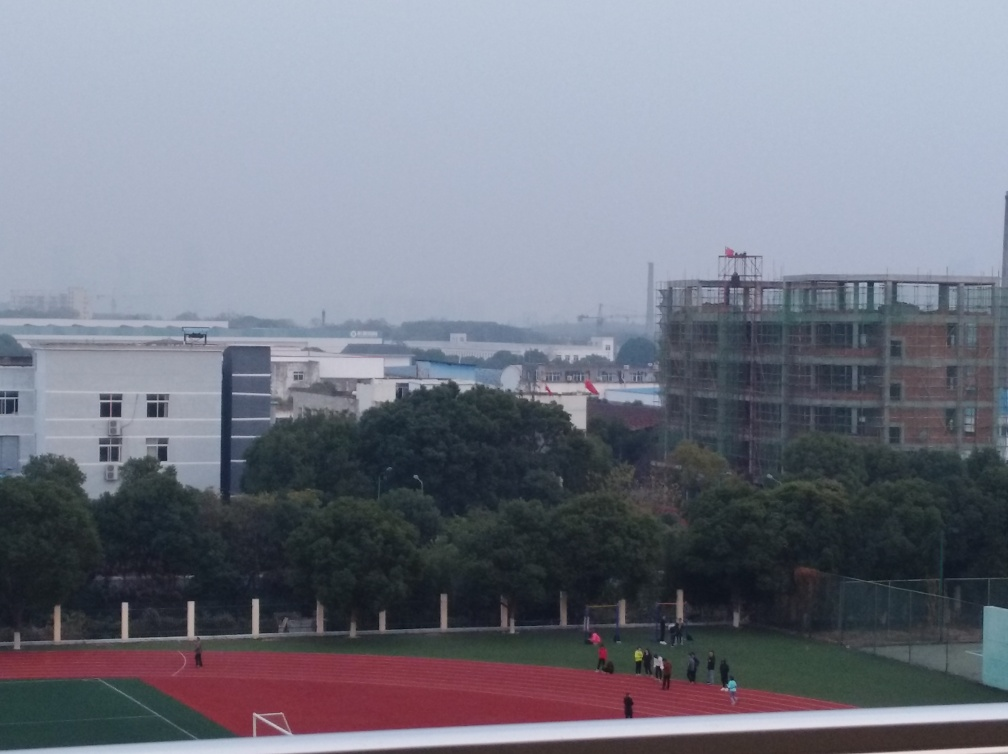What can you tell me about the weather and time of day in this image? The sky is overcast, suggesting possible cloudy weather conditions. The muted lighting and lack of shadows indicate that the image might have been taken either on a grey day or during the early morning or late afternoon hours when the sun is not very prominent. 